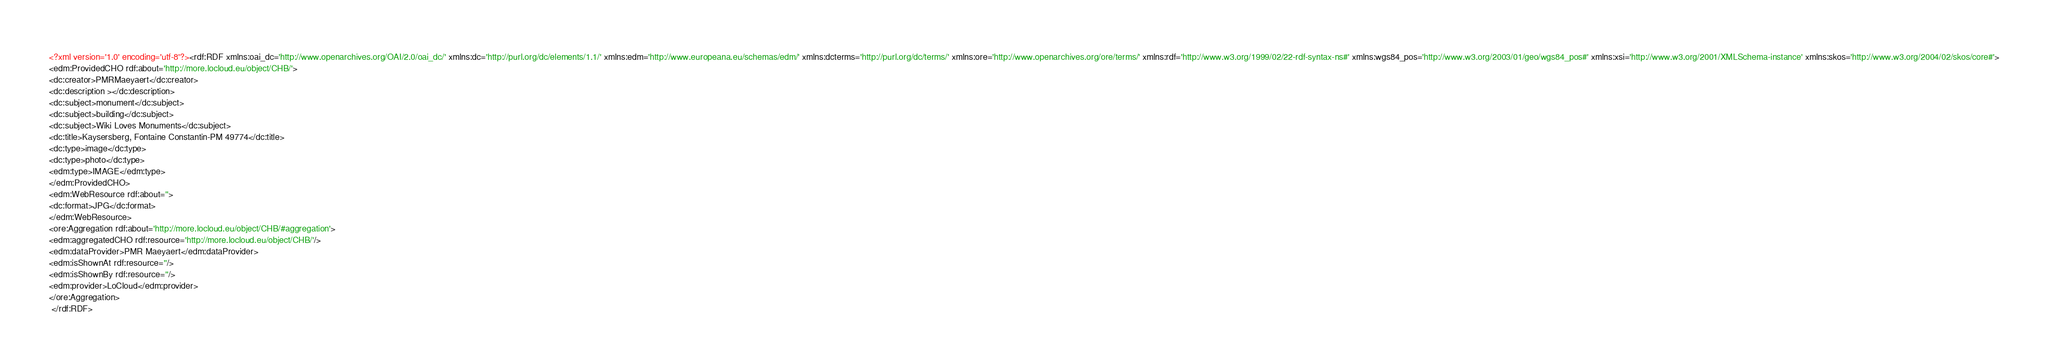Convert code to text. <code><loc_0><loc_0><loc_500><loc_500><_XML_><?xml version='1.0' encoding='utf-8'?><rdf:RDF xmlns:oai_dc='http://www.openarchives.org/OAI/2.0/oai_dc/' xmlns:dc='http://purl.org/dc/elements/1.1/' xmlns:edm='http://www.europeana.eu/schemas/edm/' xmlns:dcterms='http://purl.org/dc/terms/' xmlns:ore='http://www.openarchives.org/ore/terms/' xmlns:rdf='http://www.w3.org/1999/02/22-rdf-syntax-ns#' xmlns:wgs84_pos='http://www.w3.org/2003/01/geo/wgs84_pos#' xmlns:xsi='http://www.w3.org/2001/XMLSchema-instance' xmlns:skos='http://www.w3.org/2004/02/skos/core#'>
<edm:ProvidedCHO rdf:about='http://more.locloud.eu/object/CHB/'>
<dc:creator>PMRMaeyaert</dc:creator>
<dc:description ></dc:description>
<dc:subject>monument</dc:subject>
<dc:subject>building</dc:subject>
<dc:subject>Wiki Loves Monuments</dc:subject>
<dc:title>Kaysersberg, Fontaine Constantin-PM 49774</dc:title>
<dc:type>image</dc:type>
<dc:type>photo</dc:type>
<edm:type>IMAGE</edm:type>
</edm:ProvidedCHO>
<edm:WebResource rdf:about=''>
<dc:format>JPG</dc:format>
</edm:WebResource>
<ore:Aggregation rdf:about='http://more.locloud.eu/object/CHB/#aggregation'>
<edm:aggregatedCHO rdf:resource='http://more.locloud.eu/object/CHB/'/>
<edm:dataProvider>PMR Maeyaert</edm:dataProvider>
<edm:isShownAt rdf:resource=''/>
<edm:isShownBy rdf:resource=''/>
<edm:provider>LoCloud</edm:provider>
</ore:Aggregation>
 </rdf:RDF>
</code> 